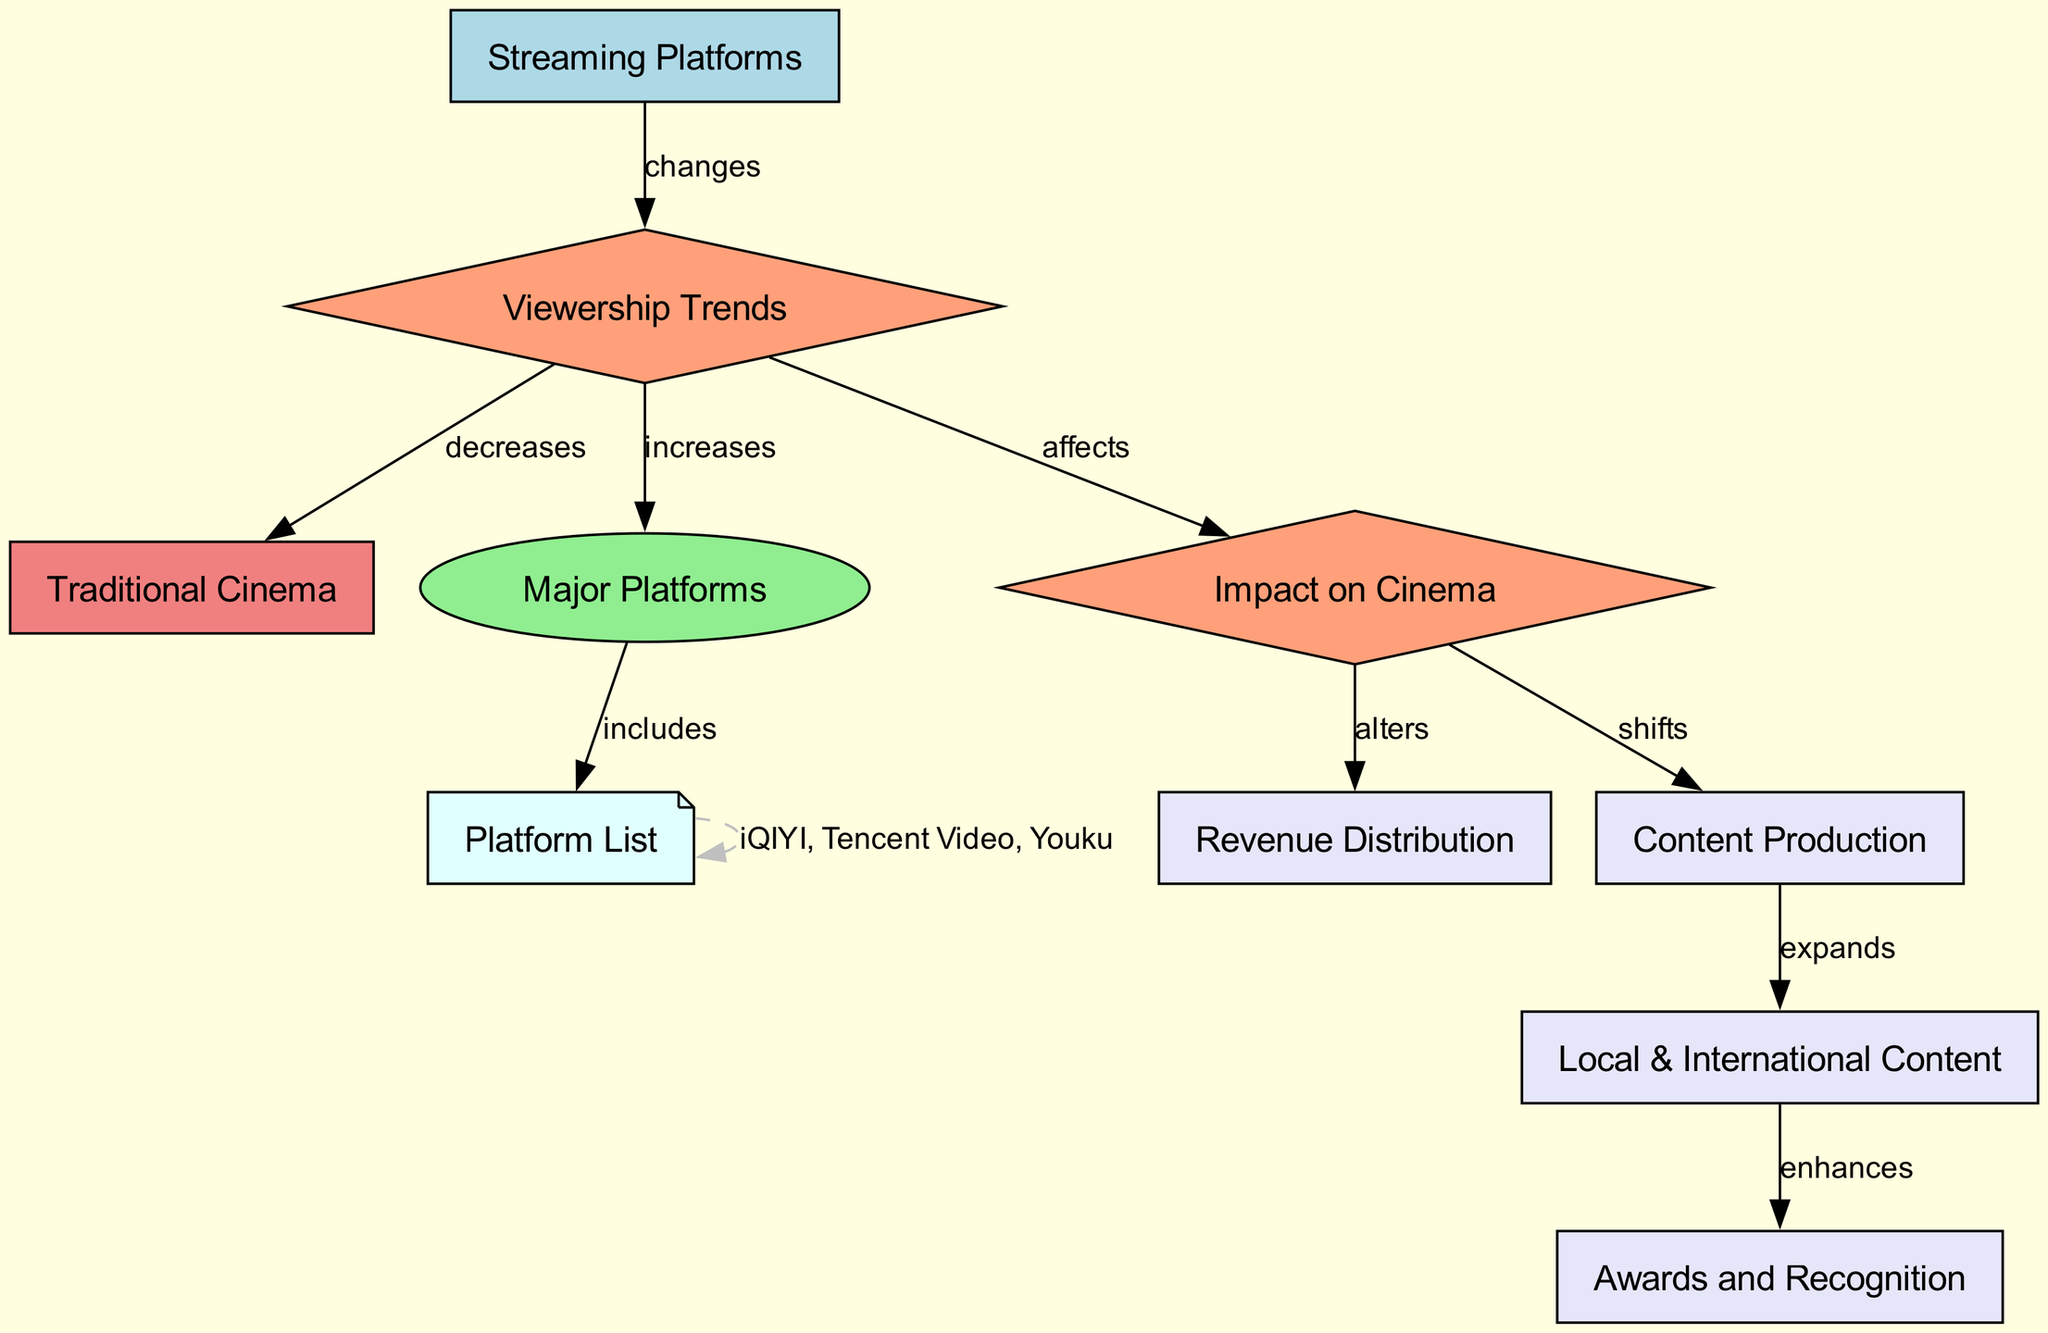what are the two main types of cinema represented in the diagram? The diagram shows two main types of cinema: "Streaming Platforms" and "Traditional Cinema." These are represented as nodes in the diagram.
Answer: Streaming Platforms, Traditional Cinema how do viewership trends impact traditional cinema? The diagram indicates that viewership trends cause a decrease in traditional cinema, linking the "viewership trends" node to the "traditional cinema" node with a labeled edge "decreases."
Answer: decreases how many major platforms are listed? The "major platforms" node connects to a "platforms list" node that contains several specific services. There are three platforms specifically named within that node, leading to the conclusion of how many major platforms are being referenced.
Answer: 3 what shifts occur as a result of the impact on cinema? According to the diagram, the "impact on cinema" leads to two shifts: it alters "revenue distribution" and shifts "content production." This is shown by the edges leading from "impact on cinema" to both of these nodes.
Answer: alters, shifts which aspect of content production does the diagram suggest expands? The diagram mentions that content production expands the creation of "Local & International Content." This relationship is established through an edge from "content production" to "local_international_content."
Answer: Local & International Content how does the presence of streaming platforms affect viewership trends? The edge from "streaming platforms" to "viewership trends" shows that the growth of streaming platforms leads to changes in viewership trends, indicating a direct relationship where the rise of these platforms impacts how viewers engage with cinema.
Answer: changes what enhances awards and recognition in the context of this diagram? The diagram illustrates that "Local & International Content" enhances "Awards and Recognition," creating a direct relationship that shows how content diversity influences award ceremonies.
Answer: enhances which node is responsible for revenue distribution? In the diagram, "revenue distribution" is connected to the "impact on cinema" node, meaning that the way revenue is allocated is a result of the effects caused by changes in the cinema landscape due to streaming platforms.
Answer: impact on cinema 